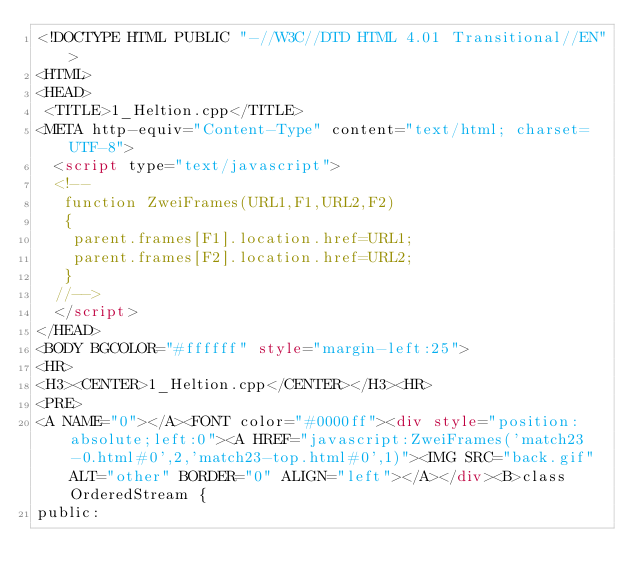Convert code to text. <code><loc_0><loc_0><loc_500><loc_500><_HTML_><!DOCTYPE HTML PUBLIC "-//W3C//DTD HTML 4.01 Transitional//EN">
<HTML>
<HEAD>
 <TITLE>1_Heltion.cpp</TITLE>
<META http-equiv="Content-Type" content="text/html; charset=UTF-8">
  <script type="text/javascript">
  <!--
   function ZweiFrames(URL1,F1,URL2,F2)
   {
    parent.frames[F1].location.href=URL1;
    parent.frames[F2].location.href=URL2;
   }
  //-->
  </script>
</HEAD>
<BODY BGCOLOR="#ffffff" style="margin-left:25">
<HR>
<H3><CENTER>1_Heltion.cpp</CENTER></H3><HR>
<PRE>
<A NAME="0"></A><FONT color="#0000ff"><div style="position:absolute;left:0"><A HREF="javascript:ZweiFrames('match23-0.html#0',2,'match23-top.html#0',1)"><IMG SRC="back.gif" ALT="other" BORDER="0" ALIGN="left"></A></div><B>class OrderedStream {
public:</code> 